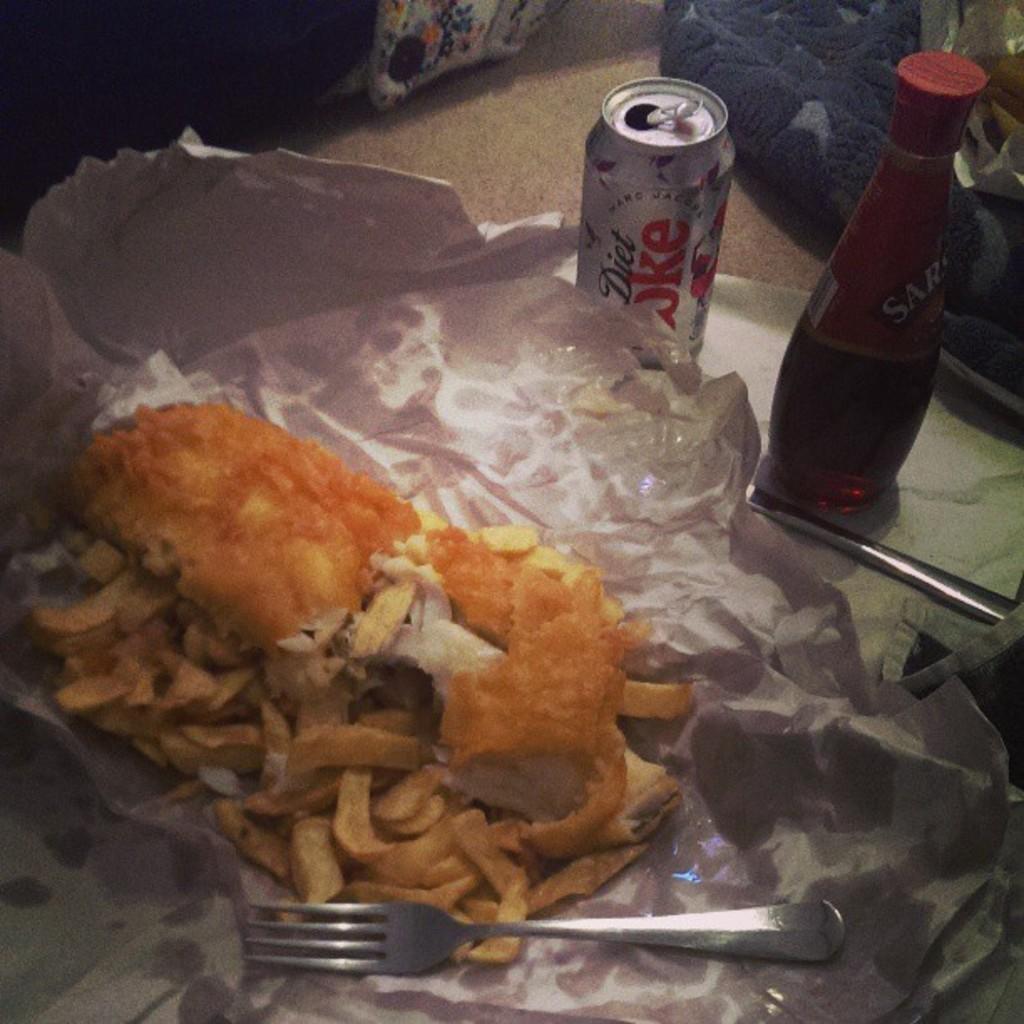In one or two sentences, can you explain what this image depicts? In this image there is a food on the paper, in the center there is a folk. At the right side there is a bottle and a tin can of diet coke. 